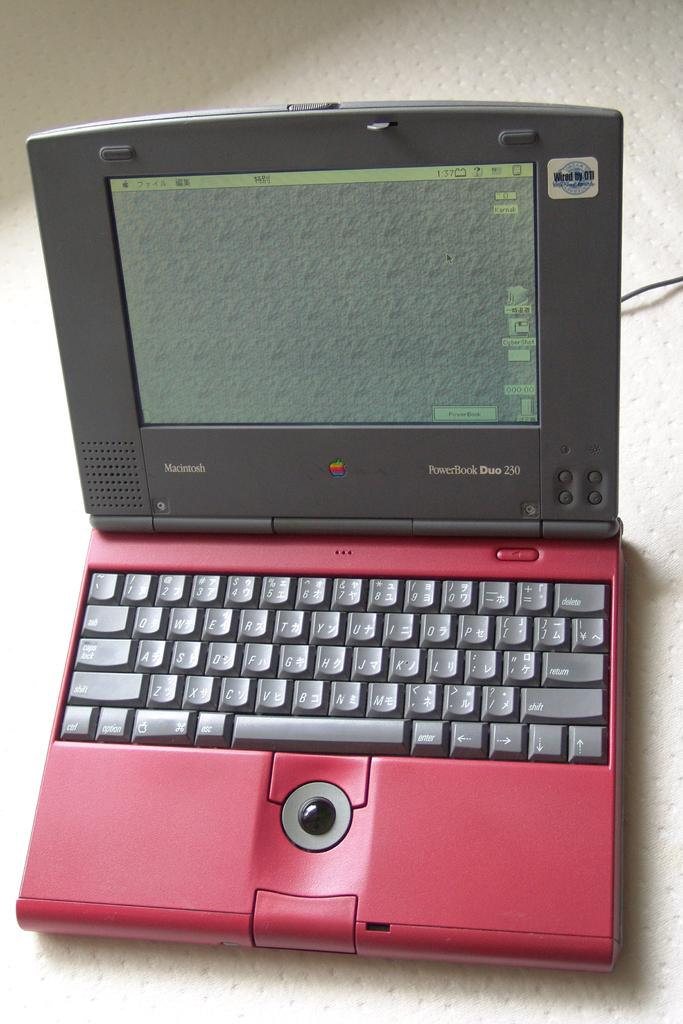<image>
Give a short and clear explanation of the subsequent image. a small apple laptop  that says powerbook duo 230 on it 